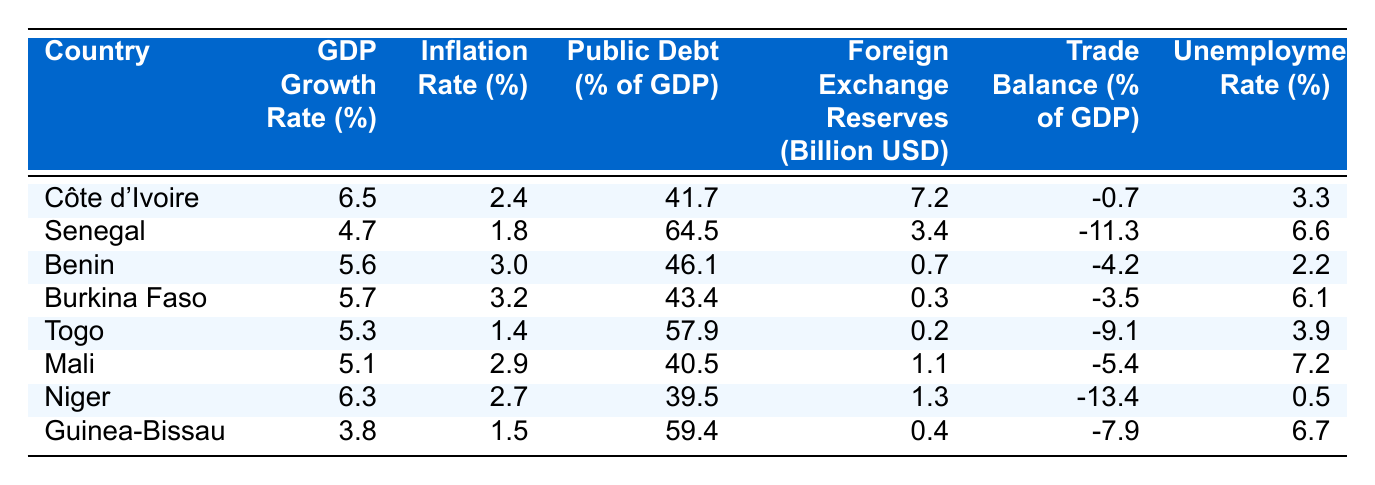What is the GDP growth rate of Côte d'Ivoire? Looking at the row for Côte d'Ivoire in the table, the GDP growth rate is given as 6.5%.
Answer: 6.5% Which country has the highest inflation rate? By comparing the inflation rates listed for each country, Senegal has the highest at 1.8%.
Answer: Senegal What is the public debt percentage of Mali? The public debt percentage for Mali is stated as 40.5% in the respective row of the table.
Answer: 40.5% Calculate the average GDP growth rate of all the countries. The GDP growth rates are: 6.5, 4.7, 5.6, 5.7, 5.3, 5.1, 6.3, and 3.8. Adding these up gives 43.0, and there are 8 countries, so the average is 43.0/8 = 5.375.
Answer: 5.375 Is the unemployment rate in Niger lower than that in Guinea-Bissau? The unemployment rate in Niger is 0.5% and in Guinea-Bissau, it is 6.7%. Since 0.5% is less than 6.7%, the statement is true.
Answer: Yes Which country has the lowest trade balance, and what is the percentage? By examining the trade balance percentages, Niger has the lowest at -13.4%, as it shows more negative trade balance than the others.
Answer: Niger, -13.4% What is the total foreign exchange reserves of the two countries with the highest reserves? The foreign exchange reserves for Côte d'Ivoire is 7.2 billion USD and for Senegal is 3.4 billion USD. Adding these gives 7.2 + 3.4 = 10.6 billion USD.
Answer: 10.6 billion USD Is it true that Burkina Faso has a higher GDP growth rate than Togo? Burkina Faso's GDP growth rate is 5.7%, while Togo's is 5.3%. Since 5.7% is greater than 5.3%, the statement is true.
Answer: Yes What is the difference in public debt percentage between Guinea-Bissau and Senegal? Guinea-Bissau has a public debt of 59.4% and Senegal has a public debt of 64.5%. The difference is 64.5 - 59.4 = 5.1%.
Answer: 5.1% Which country has a lower unemployment rate, Benin or Burkina Faso? Benin has an unemployment rate of 2.2% and Burkina Faso has 6.1%. Since 2.2% is less than 6.1%, Benin has the lower rate.
Answer: Benin 